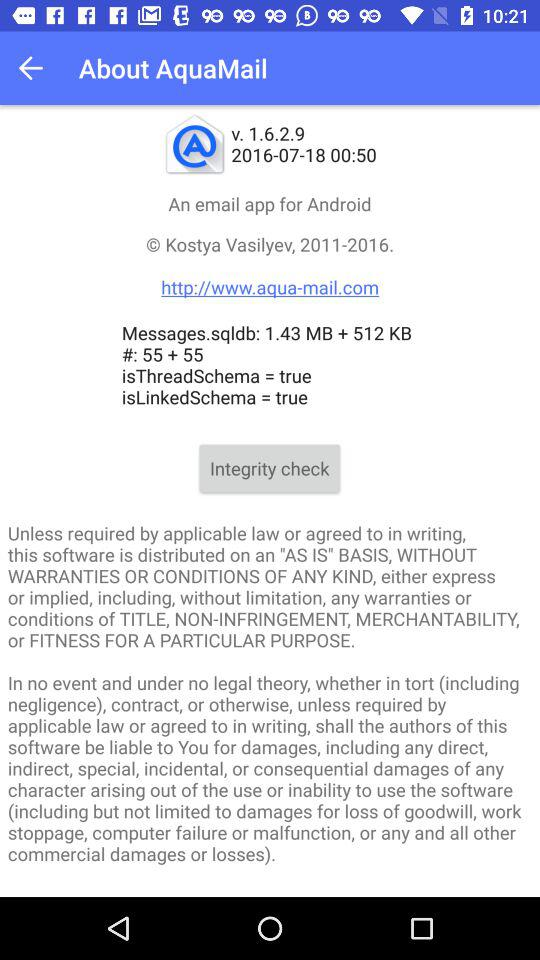How many MB of storage is used by Messages.sqldb?
Answer the question using a single word or phrase. 1.94 